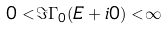Convert formula to latex. <formula><loc_0><loc_0><loc_500><loc_500>0 < \Im \Gamma _ { 0 } ( E + i 0 ) < \infty</formula> 